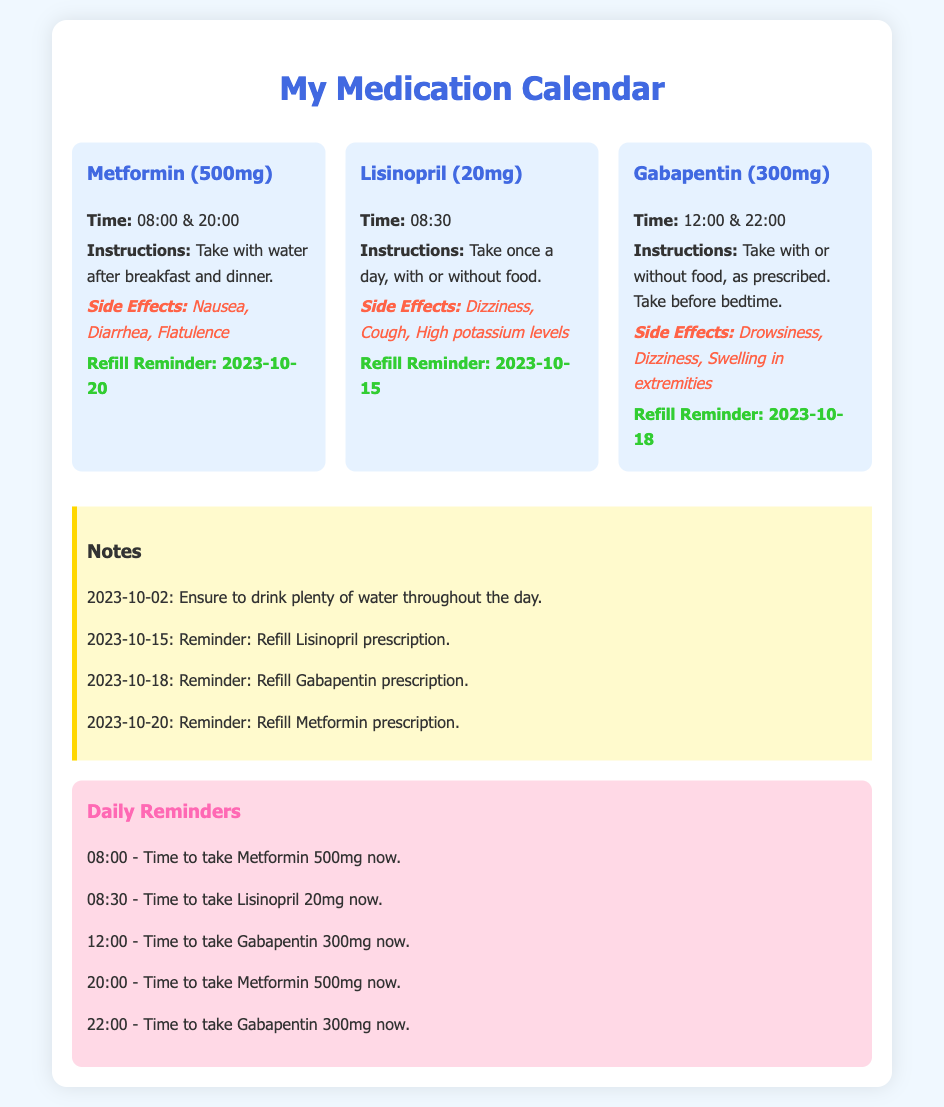What is the first medication listed? The document lists "Metformin (500mg)" as the first medication in the calendar.
Answer: Metformin (500mg) What time should I take Lisinopril? According to the document, Lisinopril should be taken at 08:30.
Answer: 08:30 What are the side effects of Gabapentin? The side effects detailed in the document for Gabapentin include drowsiness, dizziness, and swelling in extremities.
Answer: Drowsiness, Dizziness, Swelling in extremities When is the refill reminder for Metformin? The document states that the refill reminder for Metformin is on 2023-10-20.
Answer: 2023-10-20 How many times a day do I need to take Metformin? The document indicates that Metformin should be taken two times a day, in the morning and evening.
Answer: Two times What is the last reminder noted in the document? The document concludes with a reminder at 22:00 to take Gabapentin 300mg.
Answer: 22:00 What should be done on 2023-10-15? On this date, the document specifies to refill the Lisinopril prescription.
Answer: Refill Lisinopril prescription How often should Gabapentin be taken? The instructions indicate that Gabapentin is to be taken twice a day, including before bedtime.
Answer: Twice a day What background color is used for medication sections? The background color for medication sections is a soft blue, indicated in the document design.
Answer: Soft blue 